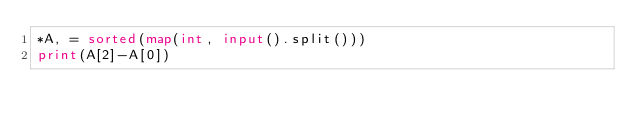Convert code to text. <code><loc_0><loc_0><loc_500><loc_500><_Python_>*A, = sorted(map(int, input().split()))
print(A[2]-A[0])
</code> 